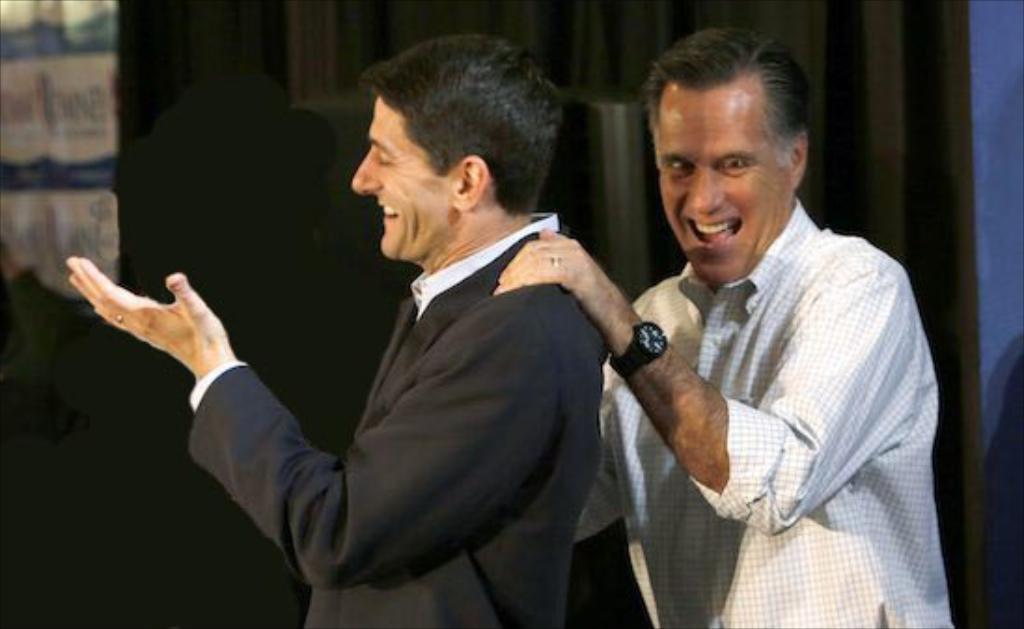Please provide a concise description of this image. In this picture I can see two persons standing and smiling, and in the background there are some objects. 